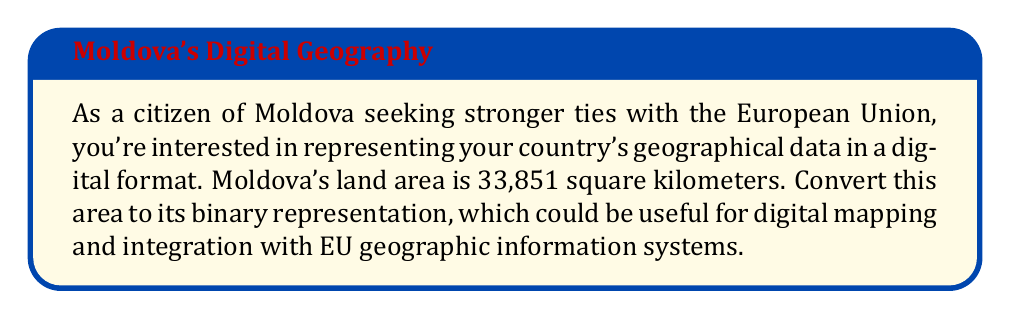Provide a solution to this math problem. To convert Moldova's area from decimal to binary, we'll follow these steps:

1) First, let's identify the largest power of 2 that's less than or equal to 33,851. This is $2^{15} = 32,768$.

2) We'll subtract this from our number:
   $33,851 - 32,768 = 1,083$

3) The next largest power of 2 less than or equal to 1,083 is $2^{10} = 1,024$.

4) Subtracting again:
   $1,083 - 1,024 = 59$

5) We continue this process:
   $59 - 32 (2^5) = 27$
   $27 - 16 (2^4) = 11$
   $11 - 8 (2^3) = 3$
   $3 - 2 (2^1) = 1$
   $1 - 1 (2^0) = 0$

6) Now, we write a 1 for each power of 2 we used, and 0 for those we didn't:

   $$\begin{array}{r}
   2^{15} = 1 \\
   2^{14} = 0 \\
   2^{13} = 0 \\
   2^{12} = 0 \\
   2^{11} = 0 \\
   2^{10} = 1 \\
   2^9 = 0 \\
   2^8 = 0 \\
   2^7 = 0 \\
   2^6 = 0 \\
   2^5 = 1 \\
   2^4 = 1 \\
   2^3 = 1 \\
   2^2 = 0 \\
   2^1 = 1 \\
   2^0 = 1
   \end{array}$$

Therefore, the binary representation of 33,851 is 1000010000011011.
Answer: 1000010000011011 